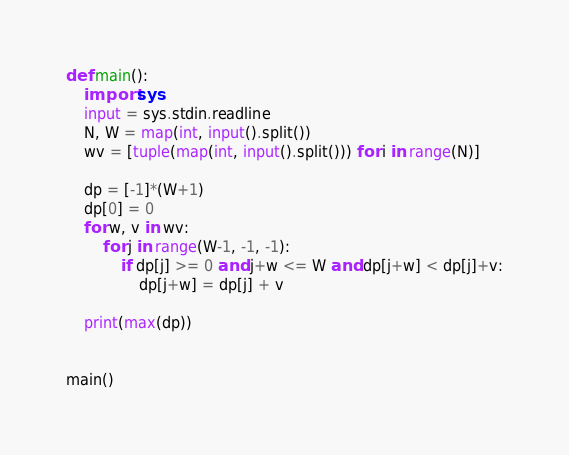Convert code to text. <code><loc_0><loc_0><loc_500><loc_500><_Python_>def main():
    import sys
    input = sys.stdin.readline
    N, W = map(int, input().split())
    wv = [tuple(map(int, input().split())) for i in range(N)]

    dp = [-1]*(W+1)
    dp[0] = 0
    for w, v in wv:
        for j in range(W-1, -1, -1):
            if dp[j] >= 0 and j+w <= W and dp[j+w] < dp[j]+v:
                dp[j+w] = dp[j] + v

    print(max(dp))


main()
</code> 